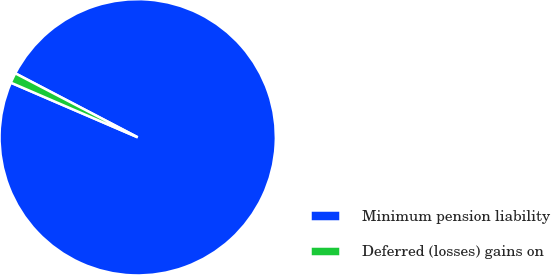<chart> <loc_0><loc_0><loc_500><loc_500><pie_chart><fcel>Minimum pension liability<fcel>Deferred (losses) gains on<nl><fcel>98.81%<fcel>1.19%<nl></chart> 